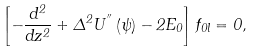<formula> <loc_0><loc_0><loc_500><loc_500>\left [ - \frac { d ^ { 2 } } { d z ^ { 2 } } + \Delta ^ { 2 } U ^ { ^ { \prime \prime } } \left ( \psi \right ) - 2 E _ { 0 } \right ] f _ { 0 l } = 0 ,</formula> 